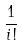<formula> <loc_0><loc_0><loc_500><loc_500>\frac { 1 } { i ! }</formula> 